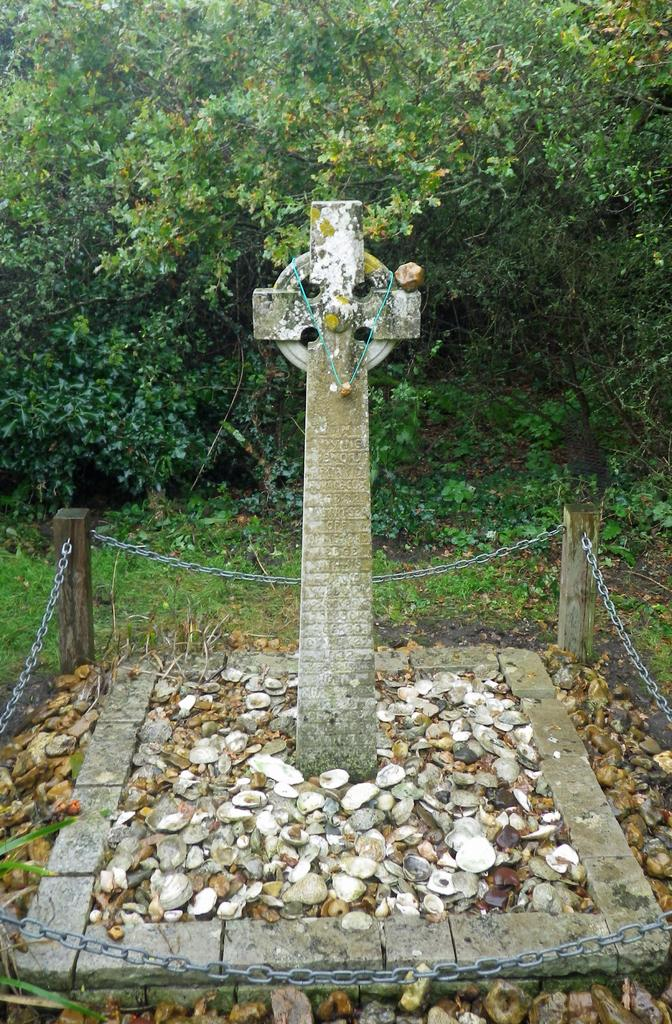What is the main object in the image? There is a memorial stone in the image. What other items can be seen around the memorial stone? There are shells, pebbles, and chains in the image. What can be seen in the background of the image? There are plants and trees in the background of the image. What type of agreement is being signed on the memorial stone in the image? There is no agreement or signing activity depicted in the image; it features a memorial stone with shells, pebbles, and chains, along with plants and trees in the background. 